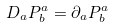Convert formula to latex. <formula><loc_0><loc_0><loc_500><loc_500>D _ { a } P ^ { a } _ { b } = \partial _ { a } P ^ { a } _ { b }</formula> 